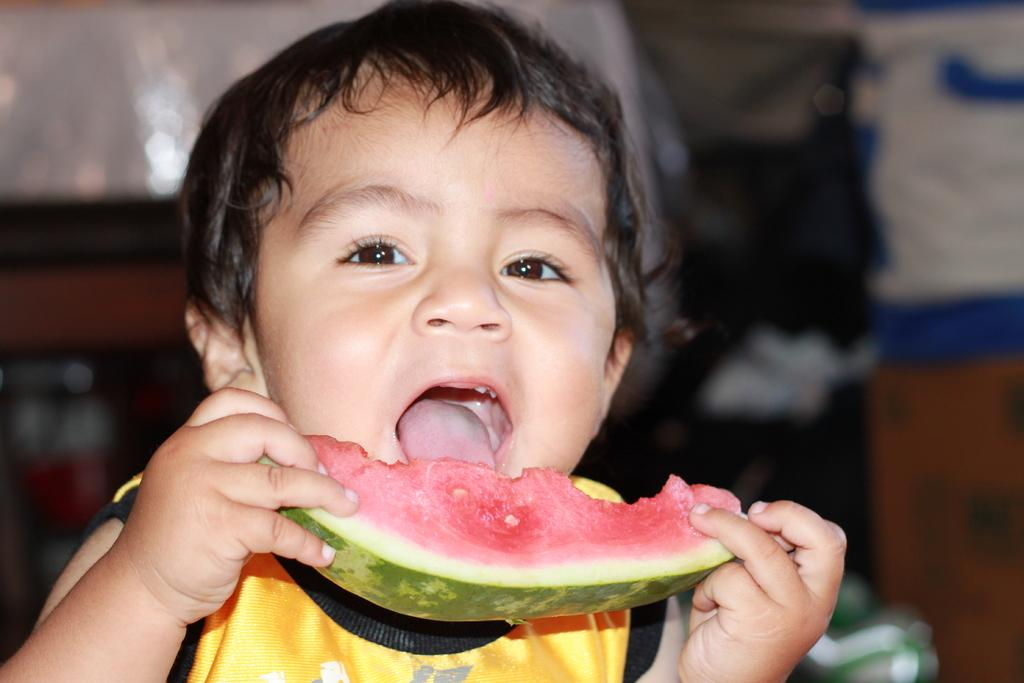Who is the main subject in the image? There is a boy in the image. What is the boy holding in the image? The boy is holding a watermelon. Can you describe the background of the image? The background of the image is blurred. What type of gold jewelry is the boy wearing in the image? There is no gold jewelry visible on the boy in the image. Can you see any cactus plants in the background of the image? There is no mention of cactus plants in the image, and the background is blurred. Is there an airplane visible in the image? There is no airplane present in the image. 